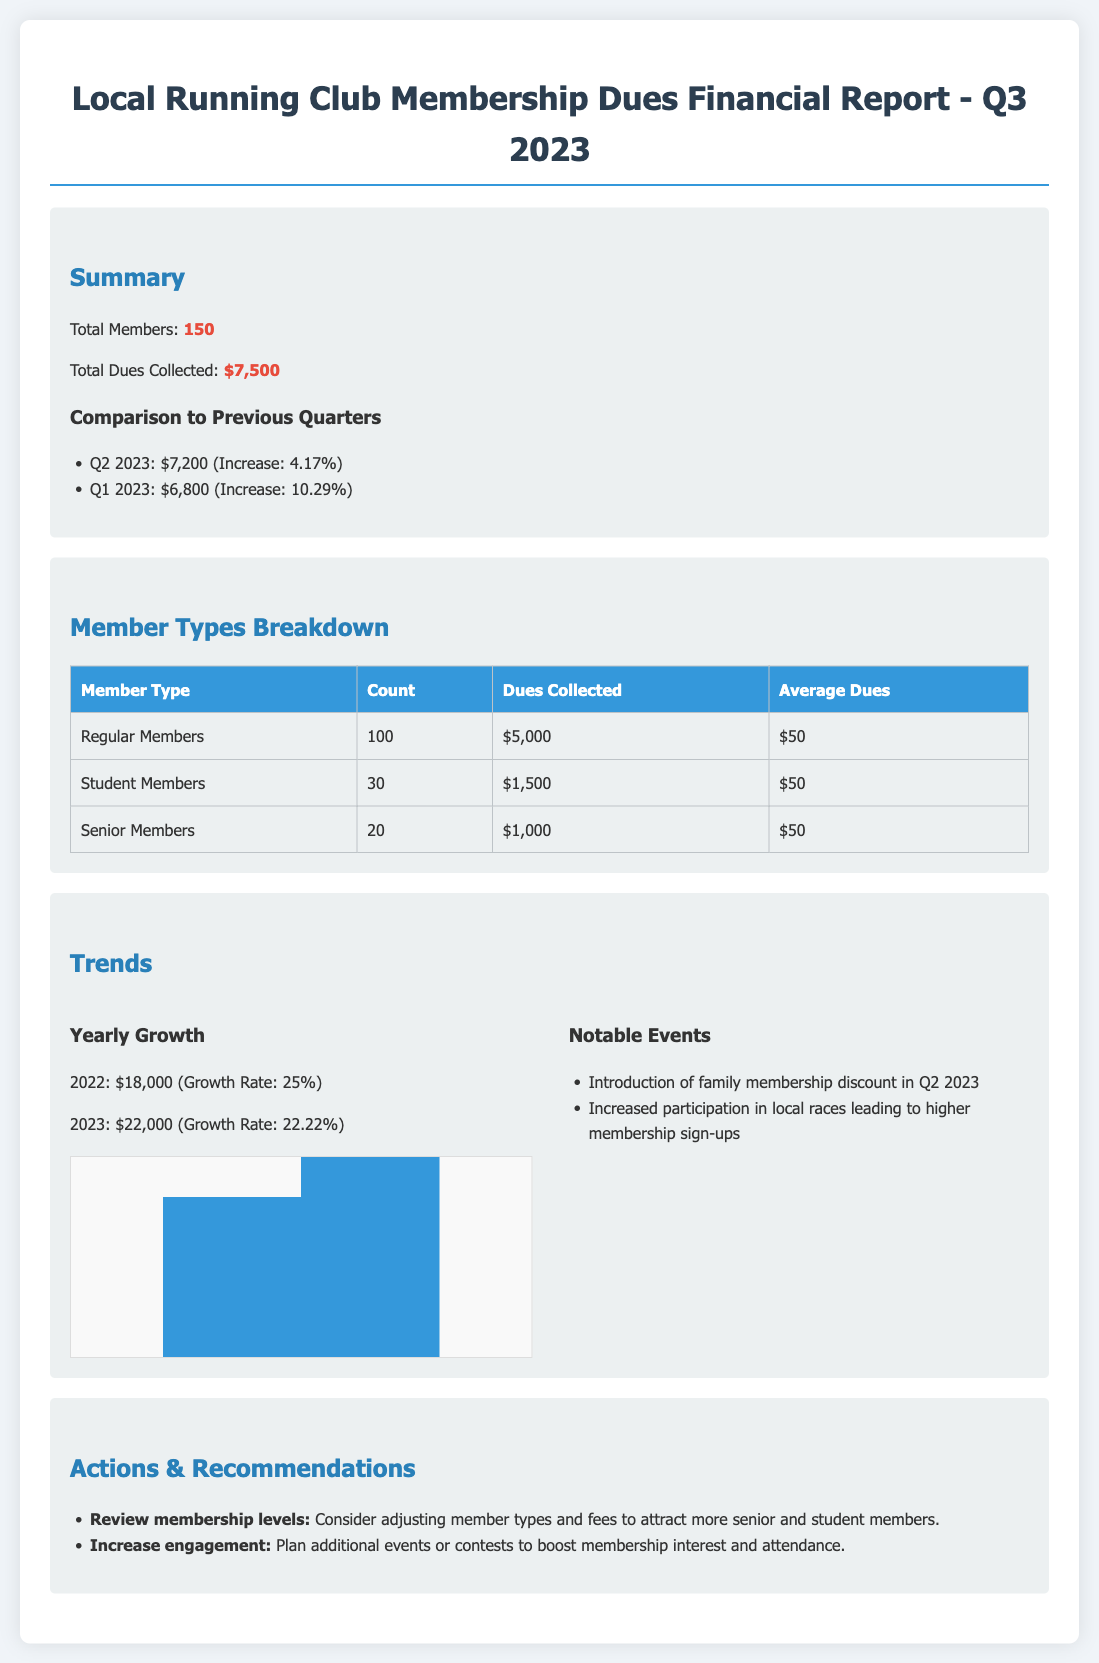What is the total membership dues collected in Q3 2023? The total dues collected for Q3 2023 is specified in the summary section of the report.
Answer: $7,500 How many total members are there? The number of total members is given in the summary section.
Answer: 150 What was the dues collected in Q2 2023? The report compares the dues collected in previous quarters, including Q2 2023.
Answer: $7,200 How much did regular members contribute to the dues? The breakdown section provides a specific contribution from regular members.
Answer: $5,000 What is the average dues collected from student members? The average dues per student member is found in the breakdown table.
Answer: $50 What was the growth rate for 2022? The growth rate for the year 2022 is stated in the trends section.
Answer: 25% What notable event happened in Q2 2023? The trends section lists notable events that impacted the club during the reported periods.
Answer: Introduction of family membership discount What is the total dues collected from senior members? The specific amount collected from senior members is stated in the breakdown table.
Answer: $1,000 What was the total dues from all 2023 quarters combined? The totals from each quarter provide this cumulative figure over the year so far.
Answer: $22,000 